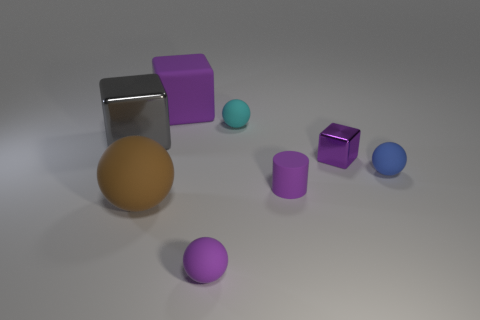Subtract all big blocks. How many blocks are left? 1 Subtract 1 cubes. How many cubes are left? 2 Subtract all cubes. How many objects are left? 5 Subtract all purple spheres. Subtract all brown blocks. How many spheres are left? 3 Subtract all brown cylinders. How many green cubes are left? 0 Subtract all large yellow blocks. Subtract all big purple objects. How many objects are left? 7 Add 7 small purple matte objects. How many small purple matte objects are left? 9 Add 7 small purple objects. How many small purple objects exist? 10 Add 1 tiny yellow metal cylinders. How many objects exist? 9 Subtract all gray blocks. How many blocks are left? 2 